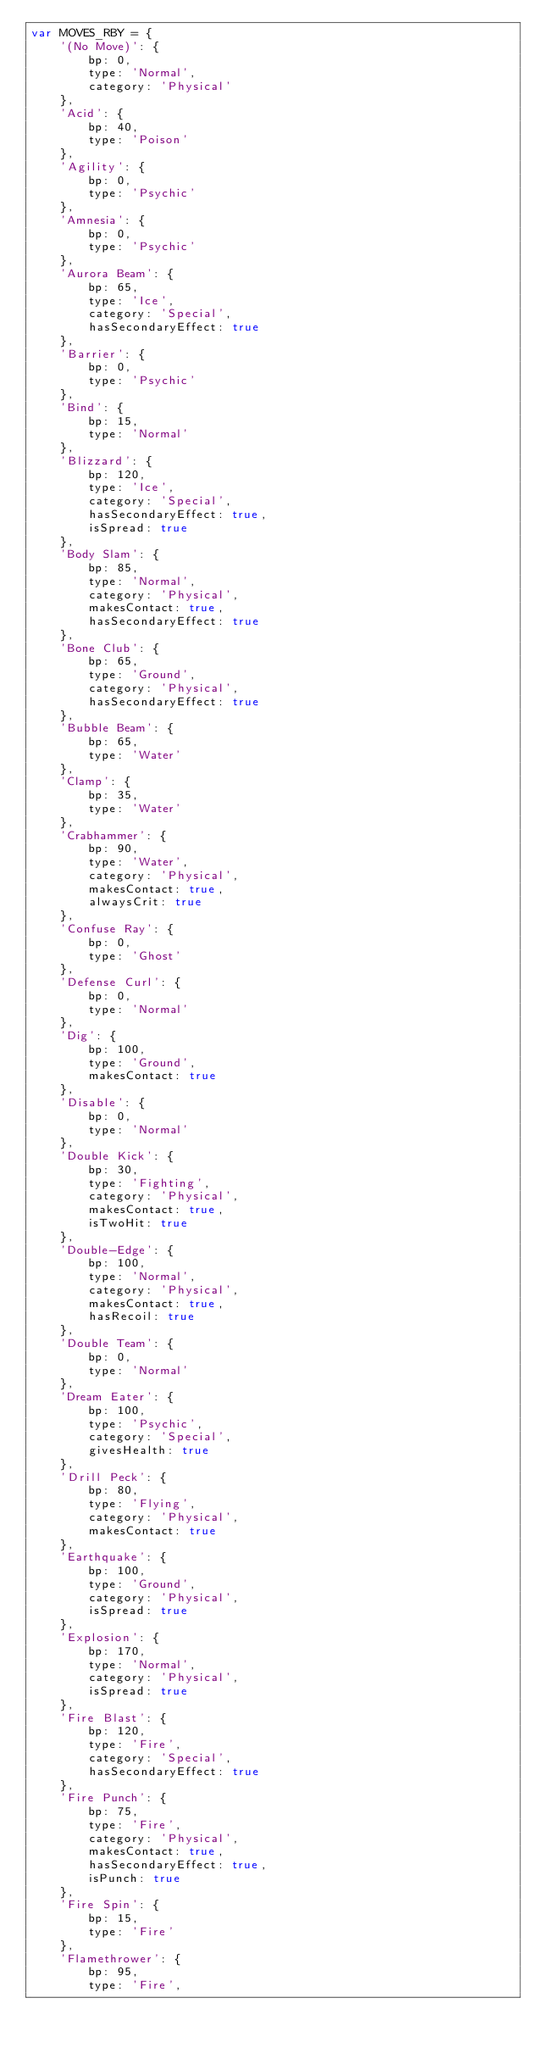<code> <loc_0><loc_0><loc_500><loc_500><_JavaScript_>var MOVES_RBY = {
    '(No Move)': {
        bp: 0,
        type: 'Normal',
        category: 'Physical'
    },
    'Acid': {
        bp: 40,
        type: 'Poison'
    },
    'Agility': {
        bp: 0,
        type: 'Psychic'
    },
    'Amnesia': {
        bp: 0,
        type: 'Psychic'
    },
    'Aurora Beam': {
        bp: 65,
        type: 'Ice',
        category: 'Special',
        hasSecondaryEffect: true
    },
    'Barrier': {
        bp: 0,
        type: 'Psychic'
    },
    'Bind': {
        bp: 15,
        type: 'Normal'
    },
    'Blizzard': {
        bp: 120,
        type: 'Ice',
        category: 'Special',
        hasSecondaryEffect: true,
        isSpread: true
    },
    'Body Slam': {
        bp: 85,
        type: 'Normal',
        category: 'Physical',
        makesContact: true,
        hasSecondaryEffect: true
    },
    'Bone Club': {
        bp: 65,
        type: 'Ground',
        category: 'Physical',
        hasSecondaryEffect: true
    },
    'Bubble Beam': {
        bp: 65,
        type: 'Water'
    },
    'Clamp': {
        bp: 35,
        type: 'Water'
    },
    'Crabhammer': {
        bp: 90,
        type: 'Water',
        category: 'Physical',
        makesContact: true,
        alwaysCrit: true
    },
    'Confuse Ray': {
        bp: 0,
        type: 'Ghost'
    },
    'Defense Curl': {
        bp: 0,
        type: 'Normal'
    },
    'Dig': {
        bp: 100,
        type: 'Ground',
        makesContact: true
    },
    'Disable': {
        bp: 0,
        type: 'Normal'
    },
    'Double Kick': {
        bp: 30,
        type: 'Fighting',
        category: 'Physical',
        makesContact: true,
        isTwoHit: true
    },
    'Double-Edge': {
        bp: 100,
        type: 'Normal',
        category: 'Physical',
        makesContact: true,
        hasRecoil: true
    },
    'Double Team': {
        bp: 0,
        type: 'Normal'
    },
    'Dream Eater': {
        bp: 100,
        type: 'Psychic',
        category: 'Special',
        givesHealth: true
    },
    'Drill Peck': {
        bp: 80,
        type: 'Flying',
        category: 'Physical',
        makesContact: true
    },
    'Earthquake': {
        bp: 100,
        type: 'Ground',
        category: 'Physical',
        isSpread: true
    },
    'Explosion': {
        bp: 170,
        type: 'Normal',
        category: 'Physical',
        isSpread: true
    },
    'Fire Blast': {
        bp: 120,
        type: 'Fire',
        category: 'Special',
        hasSecondaryEffect: true
    },
    'Fire Punch': {
        bp: 75,
        type: 'Fire',
        category: 'Physical',
        makesContact: true,
        hasSecondaryEffect: true,
        isPunch: true
    },
    'Fire Spin': {
        bp: 15,
        type: 'Fire'
    },
    'Flamethrower': {
        bp: 95,
        type: 'Fire',</code> 